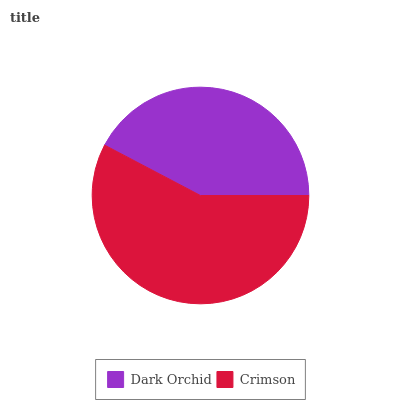Is Dark Orchid the minimum?
Answer yes or no. Yes. Is Crimson the maximum?
Answer yes or no. Yes. Is Crimson the minimum?
Answer yes or no. No. Is Crimson greater than Dark Orchid?
Answer yes or no. Yes. Is Dark Orchid less than Crimson?
Answer yes or no. Yes. Is Dark Orchid greater than Crimson?
Answer yes or no. No. Is Crimson less than Dark Orchid?
Answer yes or no. No. Is Crimson the high median?
Answer yes or no. Yes. Is Dark Orchid the low median?
Answer yes or no. Yes. Is Dark Orchid the high median?
Answer yes or no. No. Is Crimson the low median?
Answer yes or no. No. 